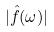Convert formula to latex. <formula><loc_0><loc_0><loc_500><loc_500>| \hat { f } ( \omega ) |</formula> 